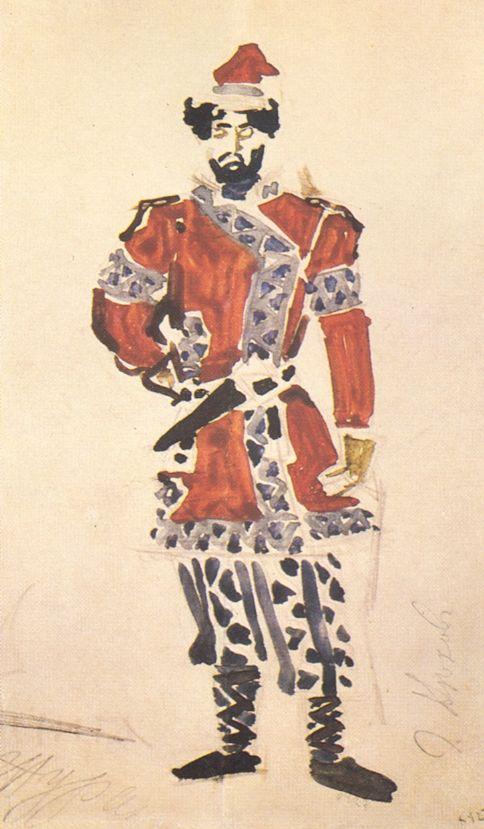What might the red hat and white feather symbolize in military uniforms? The red hat combined with a white feather in military uniforms often symbolizes bravery and high rank. Traditionally, vibrant colors like red are used to denote leadership or an elite status within the military, while feathers can indicate honor and accomplishment. This particular adornment might suggest that the individual portrayed is not only a leader but also a decorated officer recognized for his valor. 